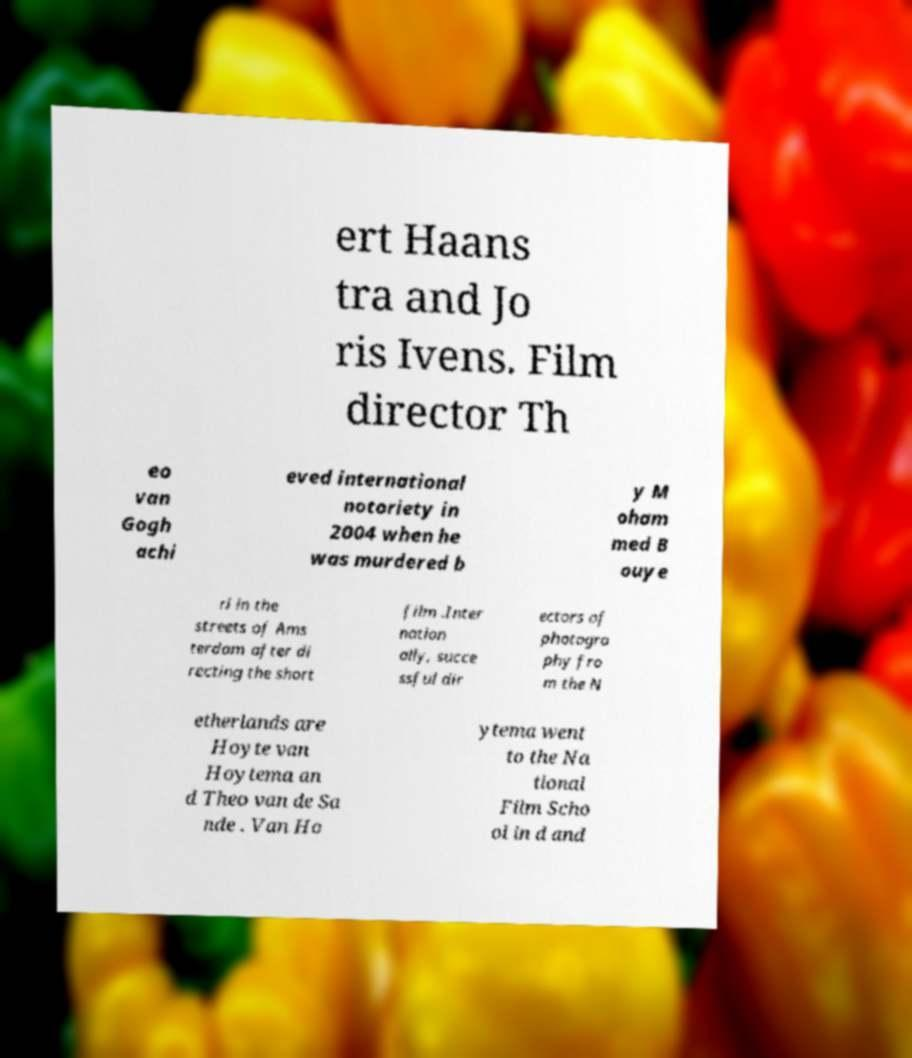Please identify and transcribe the text found in this image. ert Haans tra and Jo ris Ivens. Film director Th eo van Gogh achi eved international notoriety in 2004 when he was murdered b y M oham med B ouye ri in the streets of Ams terdam after di recting the short film .Inter nation ally, succe ssful dir ectors of photogra phy fro m the N etherlands are Hoyte van Hoytema an d Theo van de Sa nde . Van Ho ytema went to the Na tional Film Scho ol in d and 